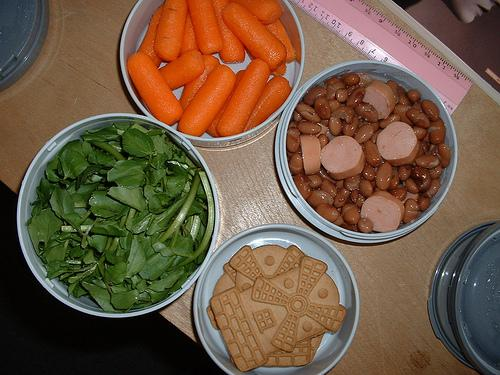What is the cookie in the shape of? windmill 